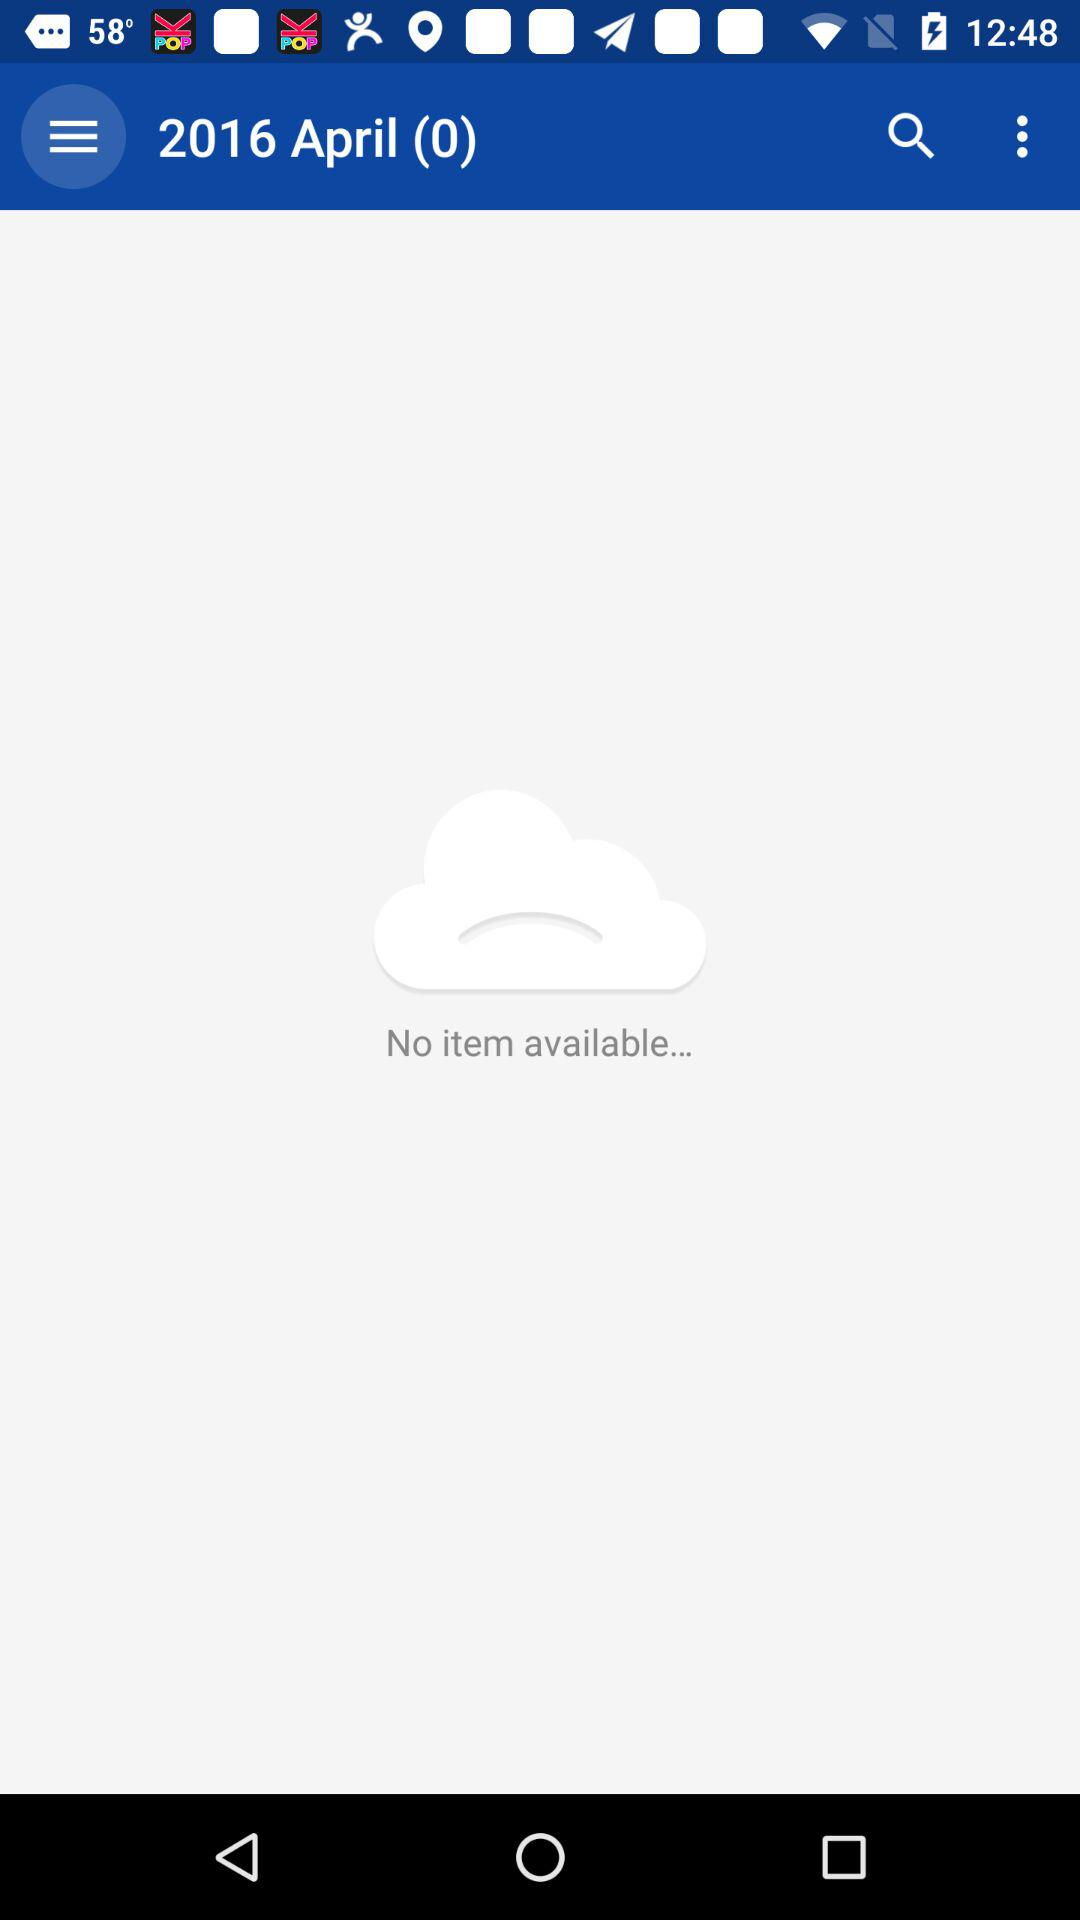Is there any item available? There is no item available. 